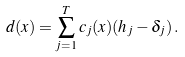Convert formula to latex. <formula><loc_0><loc_0><loc_500><loc_500>d ( x ) = \sum _ { j = 1 } ^ { T } c _ { j } ( x ) ( h _ { j } - \delta _ { j } ) \, .</formula> 